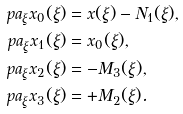<formula> <loc_0><loc_0><loc_500><loc_500>\ p a _ { \xi } x _ { 0 } ( \xi ) & = x ( \xi ) - N _ { 1 } ( \xi ) , \\ \ p a _ { \xi } x _ { 1 } ( \xi ) & = x _ { 0 } ( \xi ) , \\ \ p a _ { \xi } x _ { 2 } ( \xi ) & = - M _ { 3 } ( \xi ) , \\ \ p a _ { \xi } x _ { 3 } ( \xi ) & = + M _ { 2 } ( \xi ) .</formula> 